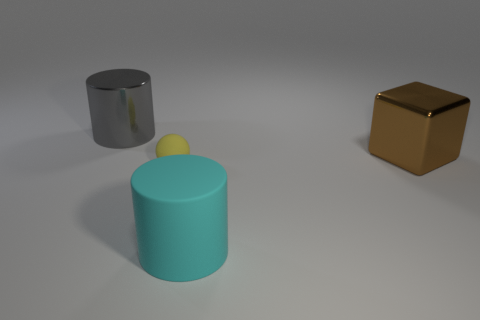Subtract all cyan cylinders. How many cylinders are left? 1 Subtract 1 cubes. How many cubes are left? 0 Add 4 brown metallic objects. How many objects exist? 8 Subtract 0 green cubes. How many objects are left? 4 Subtract all cubes. How many objects are left? 3 Subtract all yellow cubes. Subtract all blue cylinders. How many cubes are left? 1 Subtract all gray things. Subtract all brown metal cubes. How many objects are left? 2 Add 1 gray metallic cylinders. How many gray metallic cylinders are left? 2 Add 4 brown objects. How many brown objects exist? 5 